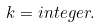<formula> <loc_0><loc_0><loc_500><loc_500>k = i n t e g e r .</formula> 